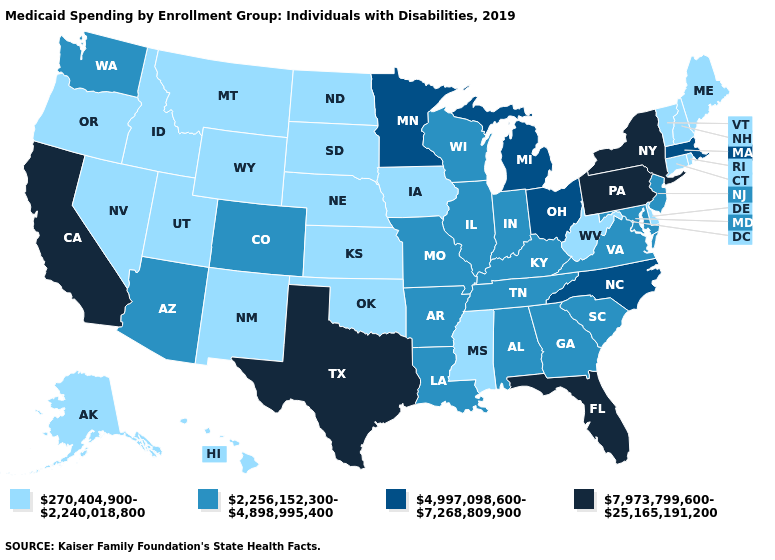Does Alaska have the lowest value in the West?
Answer briefly. Yes. Does New York have the highest value in the USA?
Give a very brief answer. Yes. Name the states that have a value in the range 2,256,152,300-4,898,995,400?
Answer briefly. Alabama, Arizona, Arkansas, Colorado, Georgia, Illinois, Indiana, Kentucky, Louisiana, Maryland, Missouri, New Jersey, South Carolina, Tennessee, Virginia, Washington, Wisconsin. What is the value of South Dakota?
Concise answer only. 270,404,900-2,240,018,800. Does Wyoming have the lowest value in the West?
Concise answer only. Yes. What is the value of Rhode Island?
Be succinct. 270,404,900-2,240,018,800. What is the lowest value in the MidWest?
Answer briefly. 270,404,900-2,240,018,800. Name the states that have a value in the range 4,997,098,600-7,268,809,900?
Keep it brief. Massachusetts, Michigan, Minnesota, North Carolina, Ohio. Name the states that have a value in the range 2,256,152,300-4,898,995,400?
Keep it brief. Alabama, Arizona, Arkansas, Colorado, Georgia, Illinois, Indiana, Kentucky, Louisiana, Maryland, Missouri, New Jersey, South Carolina, Tennessee, Virginia, Washington, Wisconsin. What is the highest value in states that border Nevada?
Quick response, please. 7,973,799,600-25,165,191,200. Does New York have the same value as Texas?
Answer briefly. Yes. What is the highest value in the USA?
Keep it brief. 7,973,799,600-25,165,191,200. What is the value of Hawaii?
Concise answer only. 270,404,900-2,240,018,800. 